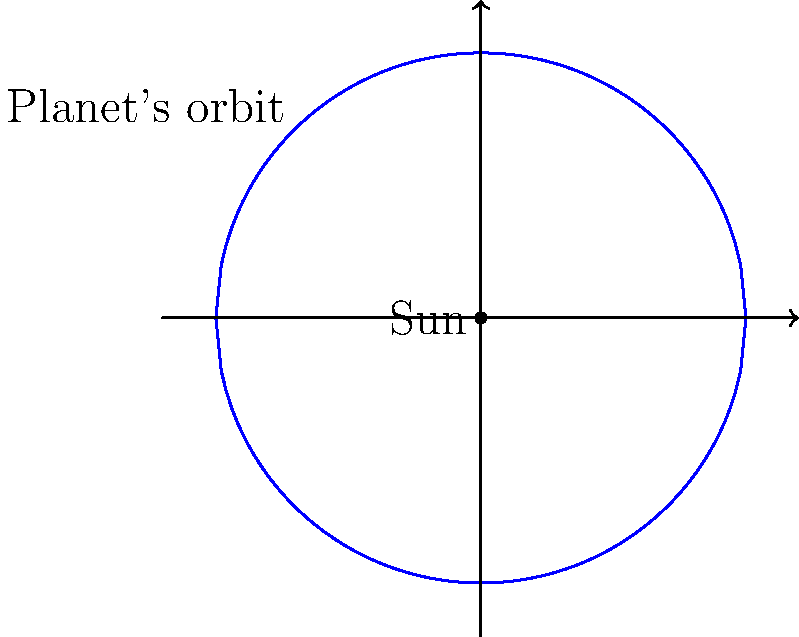In the spirit of exploring God's creation, consider the orbital path of a planet around the Sun as shown in the diagram. If we assume the orbit is perfectly circular, how does the planet's distance from the Sun change throughout its orbital period? How might this relate to the concept of divine perfection in the universe's design? Let's approach this step-by-step:

1. The diagram shows a circular orbit, which is an idealized representation of a planet's path around the Sun.

2. In a circular orbit:
   - The radius of the circle represents the distance between the planet and the Sun.
   - This radius remains constant throughout the orbit.

3. Mathematically, we can express the position of the planet using polar coordinates:
   $r = R$ (constant)
   $\theta = \omega t$
   Where $R$ is the orbit radius, $\omega$ is the angular velocity, and $t$ is time.

4. The constancy of $r$ means that the planet maintains the same distance from the Sun at all times.

5. This perfect circular motion reflects a sense of divine order and balance in the universe, reminiscent of medieval concepts of celestial perfection.

6. In reality, planetary orbits are slightly elliptical, as discovered by Johannes Kepler. This reminds us that while we strive to understand God's creation, its complexity often surpasses our initial assumptions.

7. The slight elliptical nature of real orbits doesn't diminish the beauty of the system but rather enhances our appreciation for its intricacy.

This model, while simplified, serves as a beautiful metaphor for the harmony and order in God's creation, inviting us to contemplate the universe's design and our place within it.
Answer: The distance remains constant in a circular orbit, reflecting cosmic harmony. 